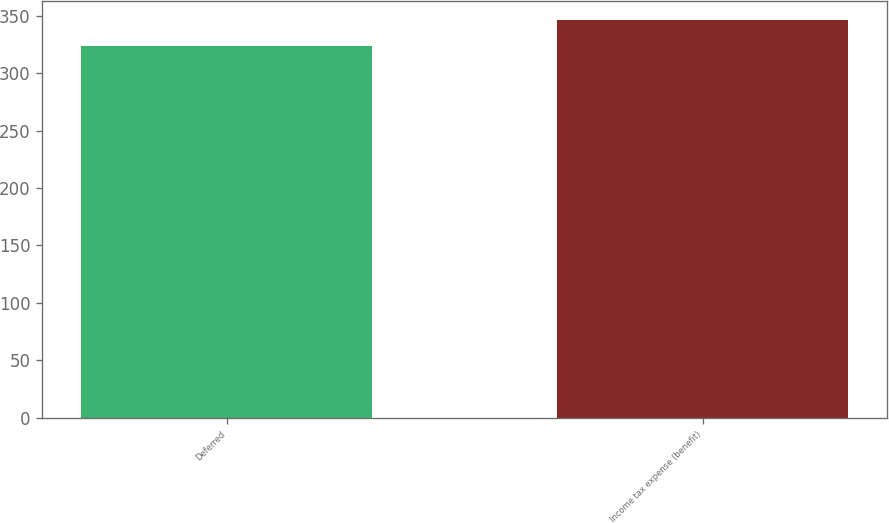Convert chart. <chart><loc_0><loc_0><loc_500><loc_500><bar_chart><fcel>Deferred<fcel>Income tax expense (benefit)<nl><fcel>324<fcel>346<nl></chart> 